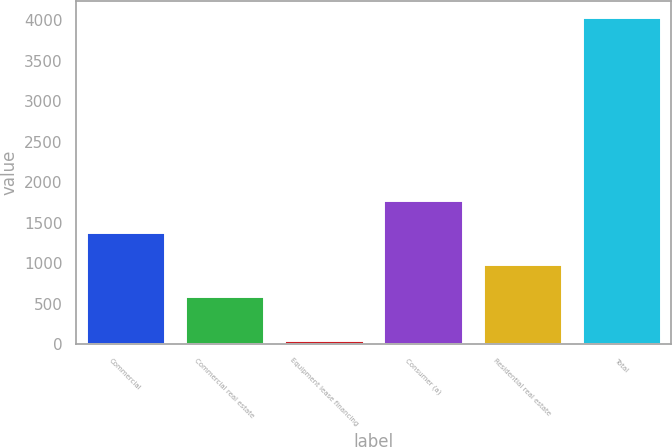<chart> <loc_0><loc_0><loc_500><loc_500><bar_chart><fcel>Commercial<fcel>Commercial real estate<fcel>Equipment lease financing<fcel>Consumer (a)<fcel>Residential real estate<fcel>Total<nl><fcel>1385.4<fcel>589<fcel>54<fcel>1783.6<fcel>987.2<fcel>4036<nl></chart> 